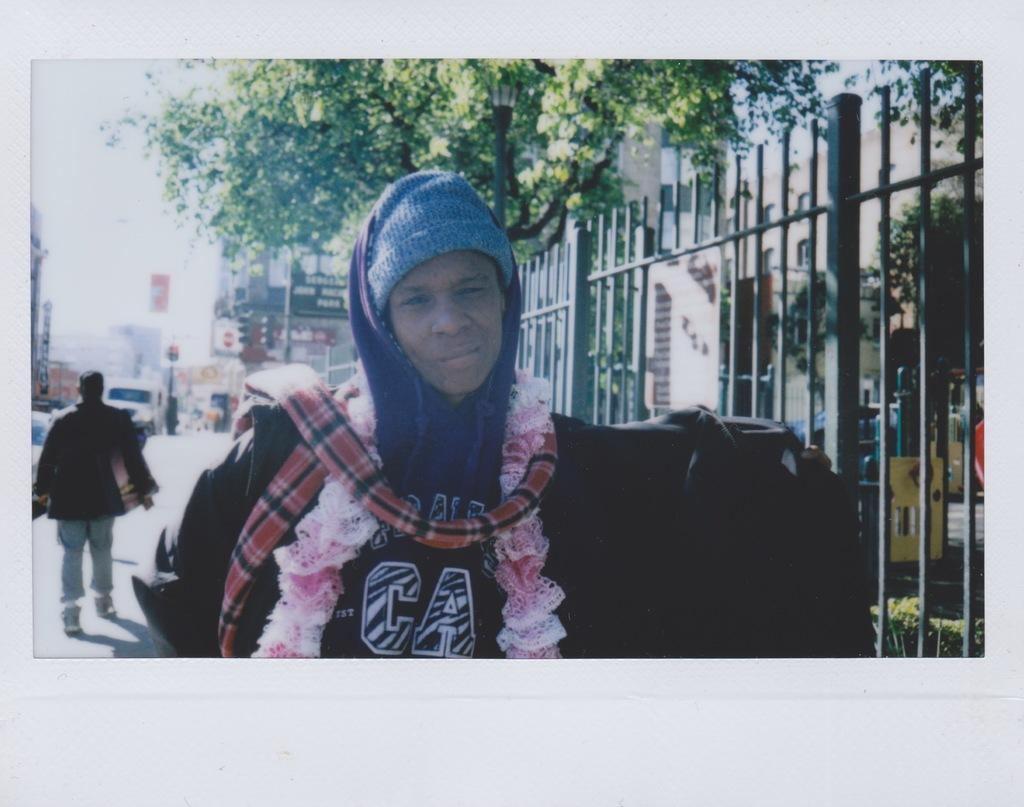<image>
Summarize the visual content of the image. A young woman wearing a hat and other clothing poses for the camera 